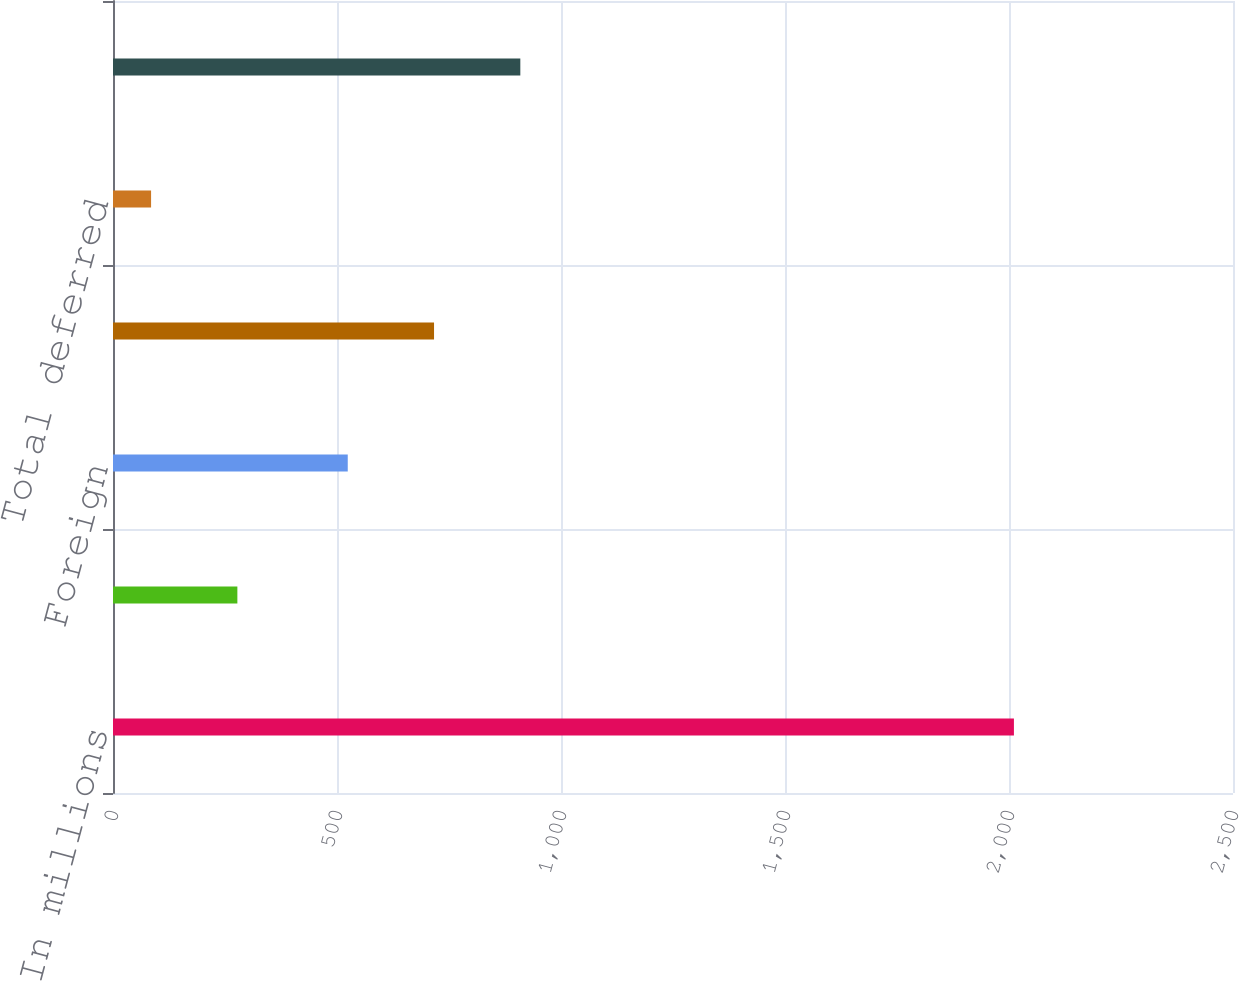<chart> <loc_0><loc_0><loc_500><loc_500><bar_chart><fcel>In millions<fcel>US federal and state<fcel>Foreign<fcel>Total current<fcel>Total deferred<fcel>Income tax expense<nl><fcel>2011<fcel>277.6<fcel>524<fcel>716.6<fcel>85<fcel>909.2<nl></chart> 